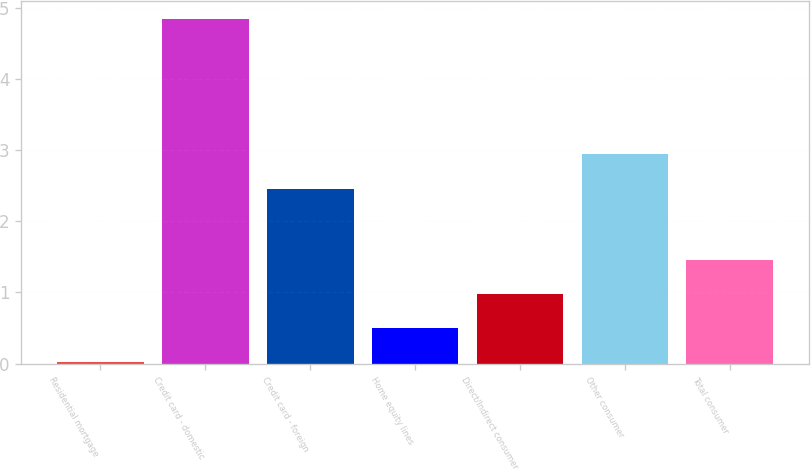Convert chart to OTSL. <chart><loc_0><loc_0><loc_500><loc_500><bar_chart><fcel>Residential mortgage<fcel>Credit card - domestic<fcel>Credit card - foreign<fcel>Home equity lines<fcel>Direct/Indirect consumer<fcel>Other consumer<fcel>Total consumer<nl><fcel>0.02<fcel>4.85<fcel>2.46<fcel>0.5<fcel>0.98<fcel>2.94<fcel>1.46<nl></chart> 